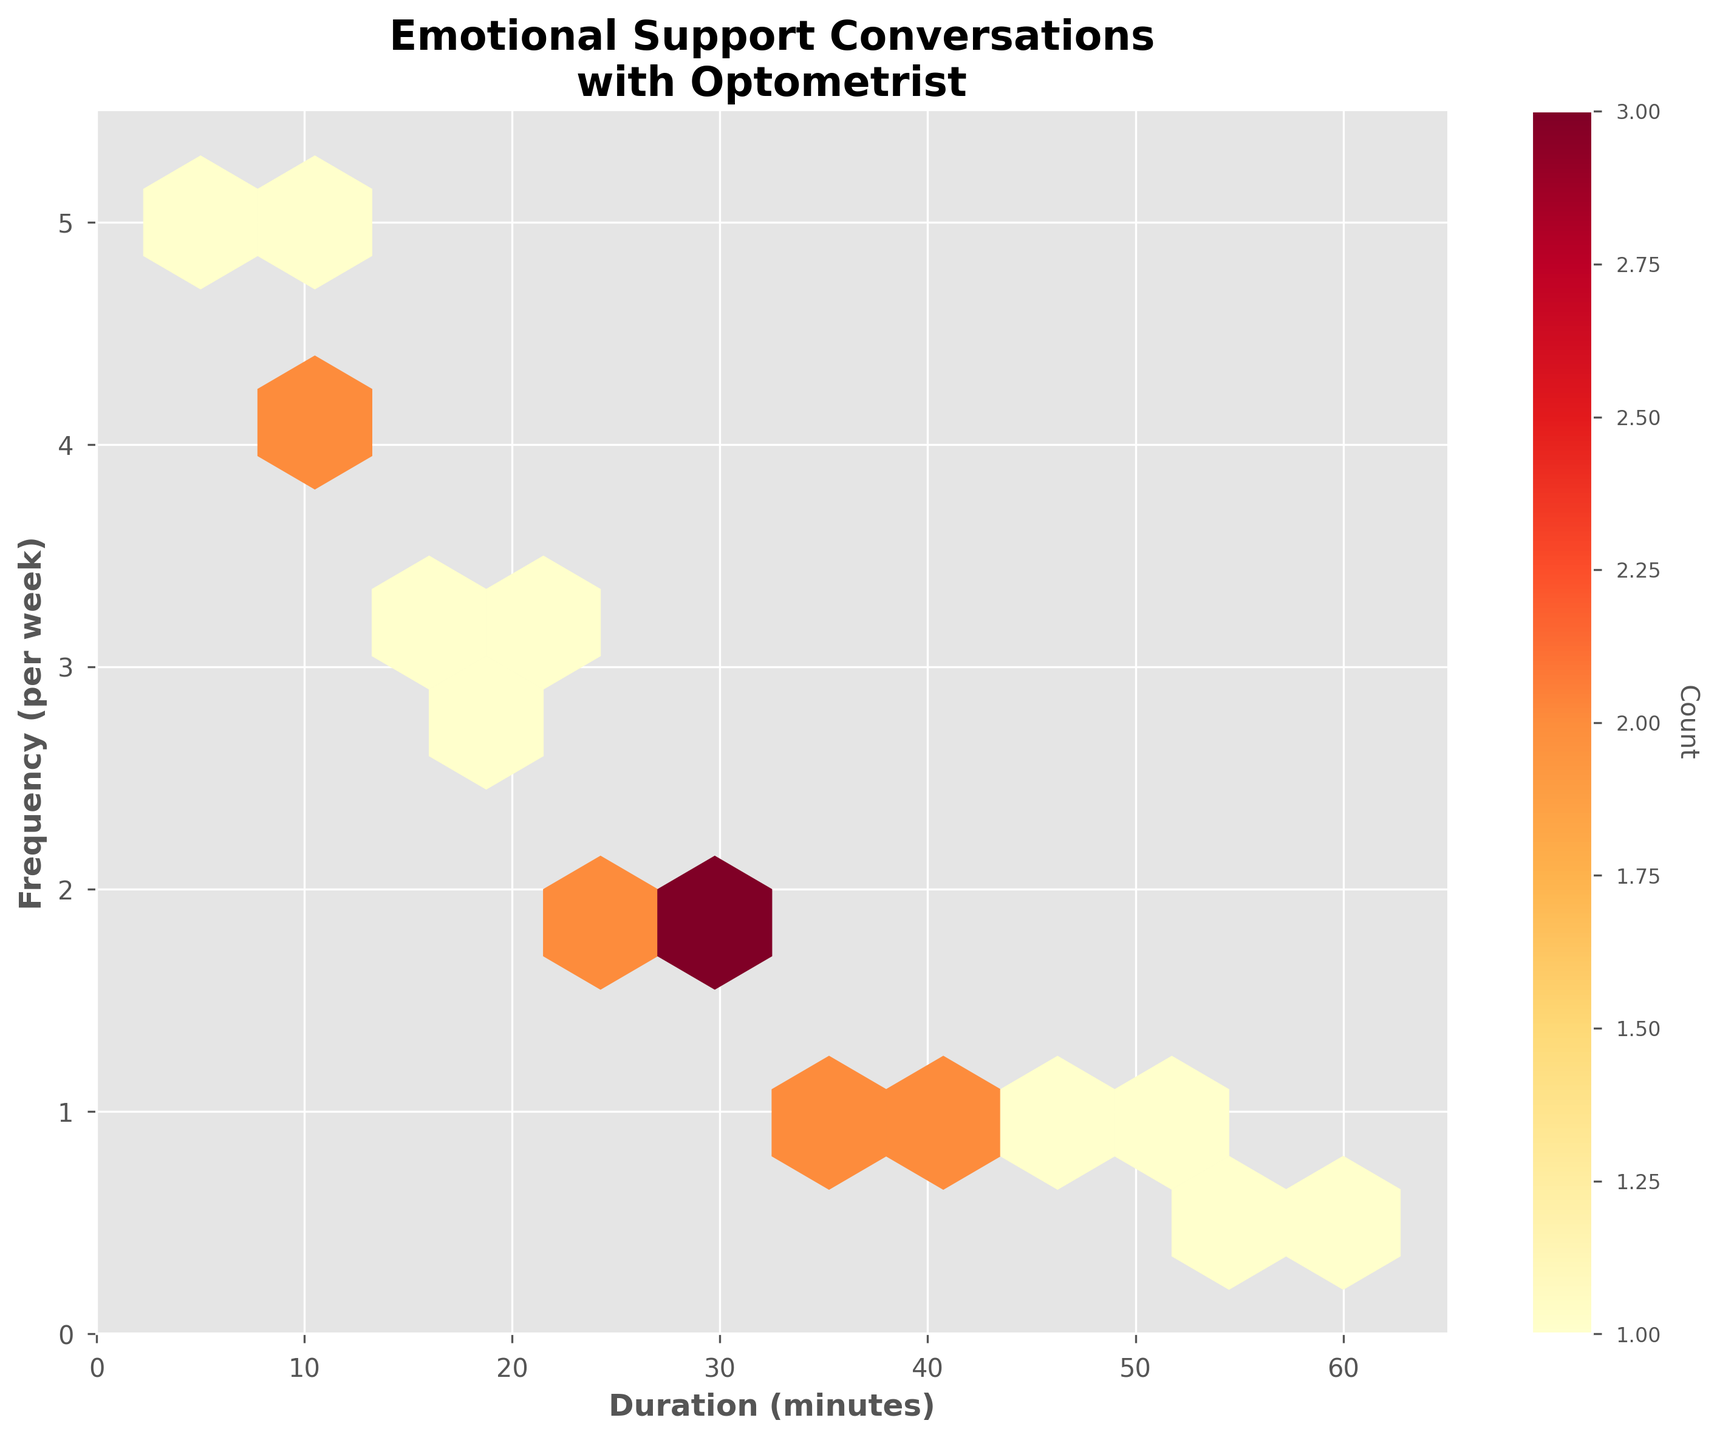What is the title of the hexbin plot? The title of the plot is displayed at the top and reads "Emotional Support Conversations with Optometrist".
Answer: Emotional Support Conversations with Optometrist What are the x-axis and y-axis labels? The x-axis is labeled "Duration (minutes)" and the y-axis is labeled "Frequency (per week)".
Answer: Duration (minutes); Frequency (per week) In what range do the durations of conversations typically fall? The x-axis ranges from 0 to 65 minutes, indicating conversation durations fall within this range.
Answer: 0 to 65 minutes Where are the highest density of points located on the plot? The highest density of points can be determined by the color intensity; the darkest hexagons show the highest count. Here, the highest density is around durations of 10 to 20 minutes and frequencies of 3 to 4 times per week.
Answer: Around 10 to 20 minutes duration and 3 to 4 times per week frequency How many hexagons are there with exactly 1 count? By looking at the color legend and referring to the color of hexagons on the plot, several hexagons match the color for a count of 1.
Answer: Several (exact number not visible without data source) What is the average duration of emotional support conversations for frequencies over 3 times per week? Identify the hexagons with frequencies over 3 on the y-axis and observe the corresponding x-axis values for these hexagons to calculate the average.
Answer: Around 7 to 15 minutes Are there any conversations which lasted for around 60 minutes? Locate the hexagon near the x-axis value of 60; there is a single hexagon indicating a frequency, confirming such durations exist.
Answer: Yes What is the trend between the duration and frequency of conversations? Observing the plot, a higher frequency of emotional support conversations is generally associated with shorter durations. Longer durations correspond to lower frequencies.
Answer: Higher frequency generally associates with shorter duration How does the frequency of conversations change as the duration increases from 5 to 60 minutes? By following the hexagons horizontally along the x-axis from 5 to 60, it is clear that the frequency of conversations decreases as the duration increases.
Answer: Decreases as duration increases 